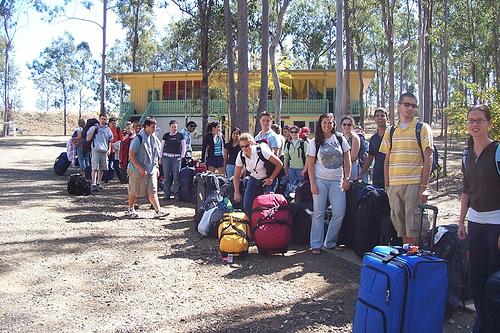How many suitcases are visible?
Give a very brief answer. 11. How many visible people are wearing yellow?
Answer briefly. 1. Are these people waiting?
Give a very brief answer. Yes. 